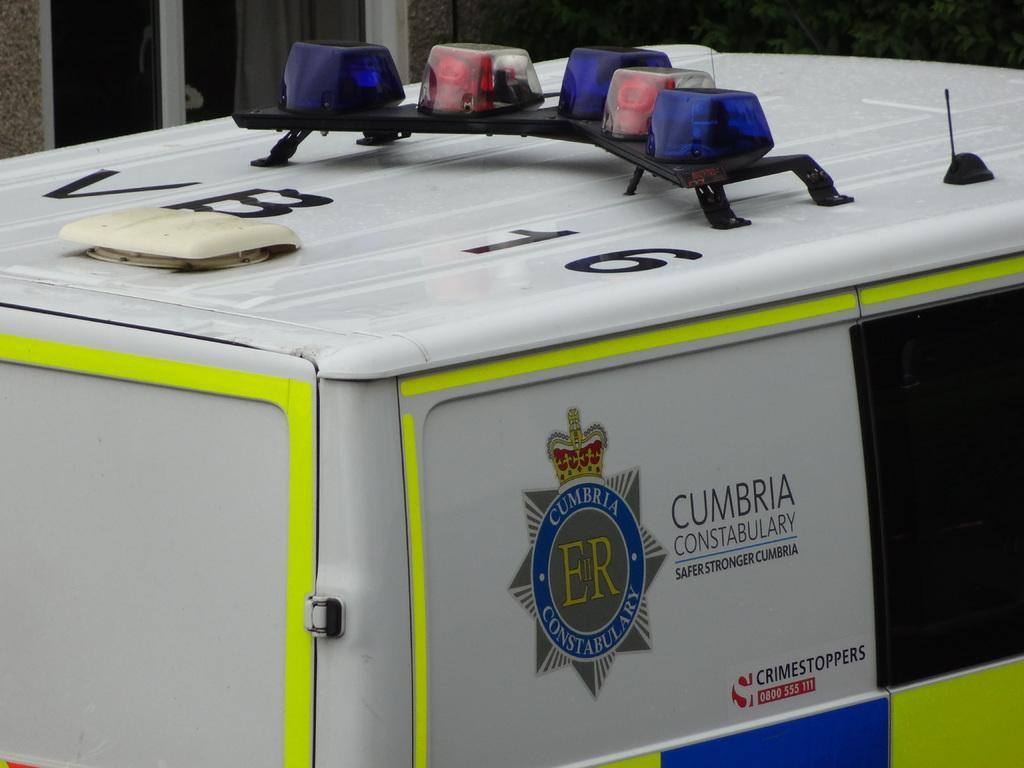What is present on the top surface of the vehicle in the image? There are lights in different colors on the top surface of the vehicle. What is the color of the vehicle? The vehicle is white in color. How do the lights measure the distance to the nearest tub in the image? There is no tub present in the image, and the lights do not have the capability to measure distance. 